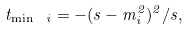Convert formula to latex. <formula><loc_0><loc_0><loc_500><loc_500>t _ { \min \ i } = - ( s - m _ { i } ^ { 2 } ) ^ { 2 } / s ,</formula> 